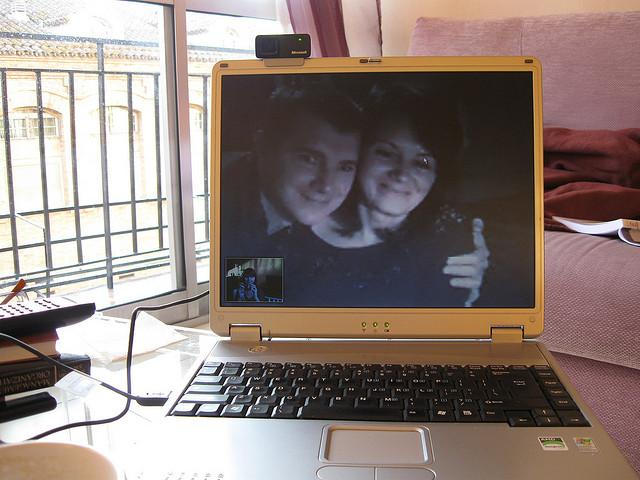Who is using this laptop? Please explain your reasoning. girl. A girl is using the laptop. 